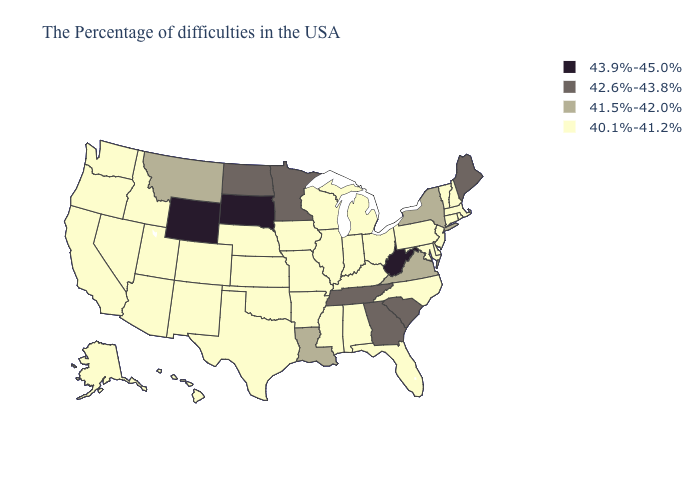Which states have the lowest value in the USA?
Quick response, please. Massachusetts, Rhode Island, New Hampshire, Vermont, Connecticut, New Jersey, Delaware, Maryland, Pennsylvania, North Carolina, Ohio, Florida, Michigan, Kentucky, Indiana, Alabama, Wisconsin, Illinois, Mississippi, Missouri, Arkansas, Iowa, Kansas, Nebraska, Oklahoma, Texas, Colorado, New Mexico, Utah, Arizona, Idaho, Nevada, California, Washington, Oregon, Alaska, Hawaii. What is the lowest value in the USA?
Answer briefly. 40.1%-41.2%. What is the lowest value in the USA?
Write a very short answer. 40.1%-41.2%. Does Tennessee have the lowest value in the USA?
Answer briefly. No. Is the legend a continuous bar?
Give a very brief answer. No. What is the value of Tennessee?
Quick response, please. 42.6%-43.8%. What is the highest value in the USA?
Give a very brief answer. 43.9%-45.0%. Name the states that have a value in the range 41.5%-42.0%?
Answer briefly. New York, Virginia, Louisiana, Montana. Does West Virginia have the lowest value in the USA?
Be succinct. No. What is the value of Texas?
Quick response, please. 40.1%-41.2%. Does California have a lower value than New York?
Keep it brief. Yes. Does Ohio have the highest value in the USA?
Be succinct. No. How many symbols are there in the legend?
Give a very brief answer. 4. Does the map have missing data?
Answer briefly. No. What is the value of Maine?
Keep it brief. 42.6%-43.8%. 